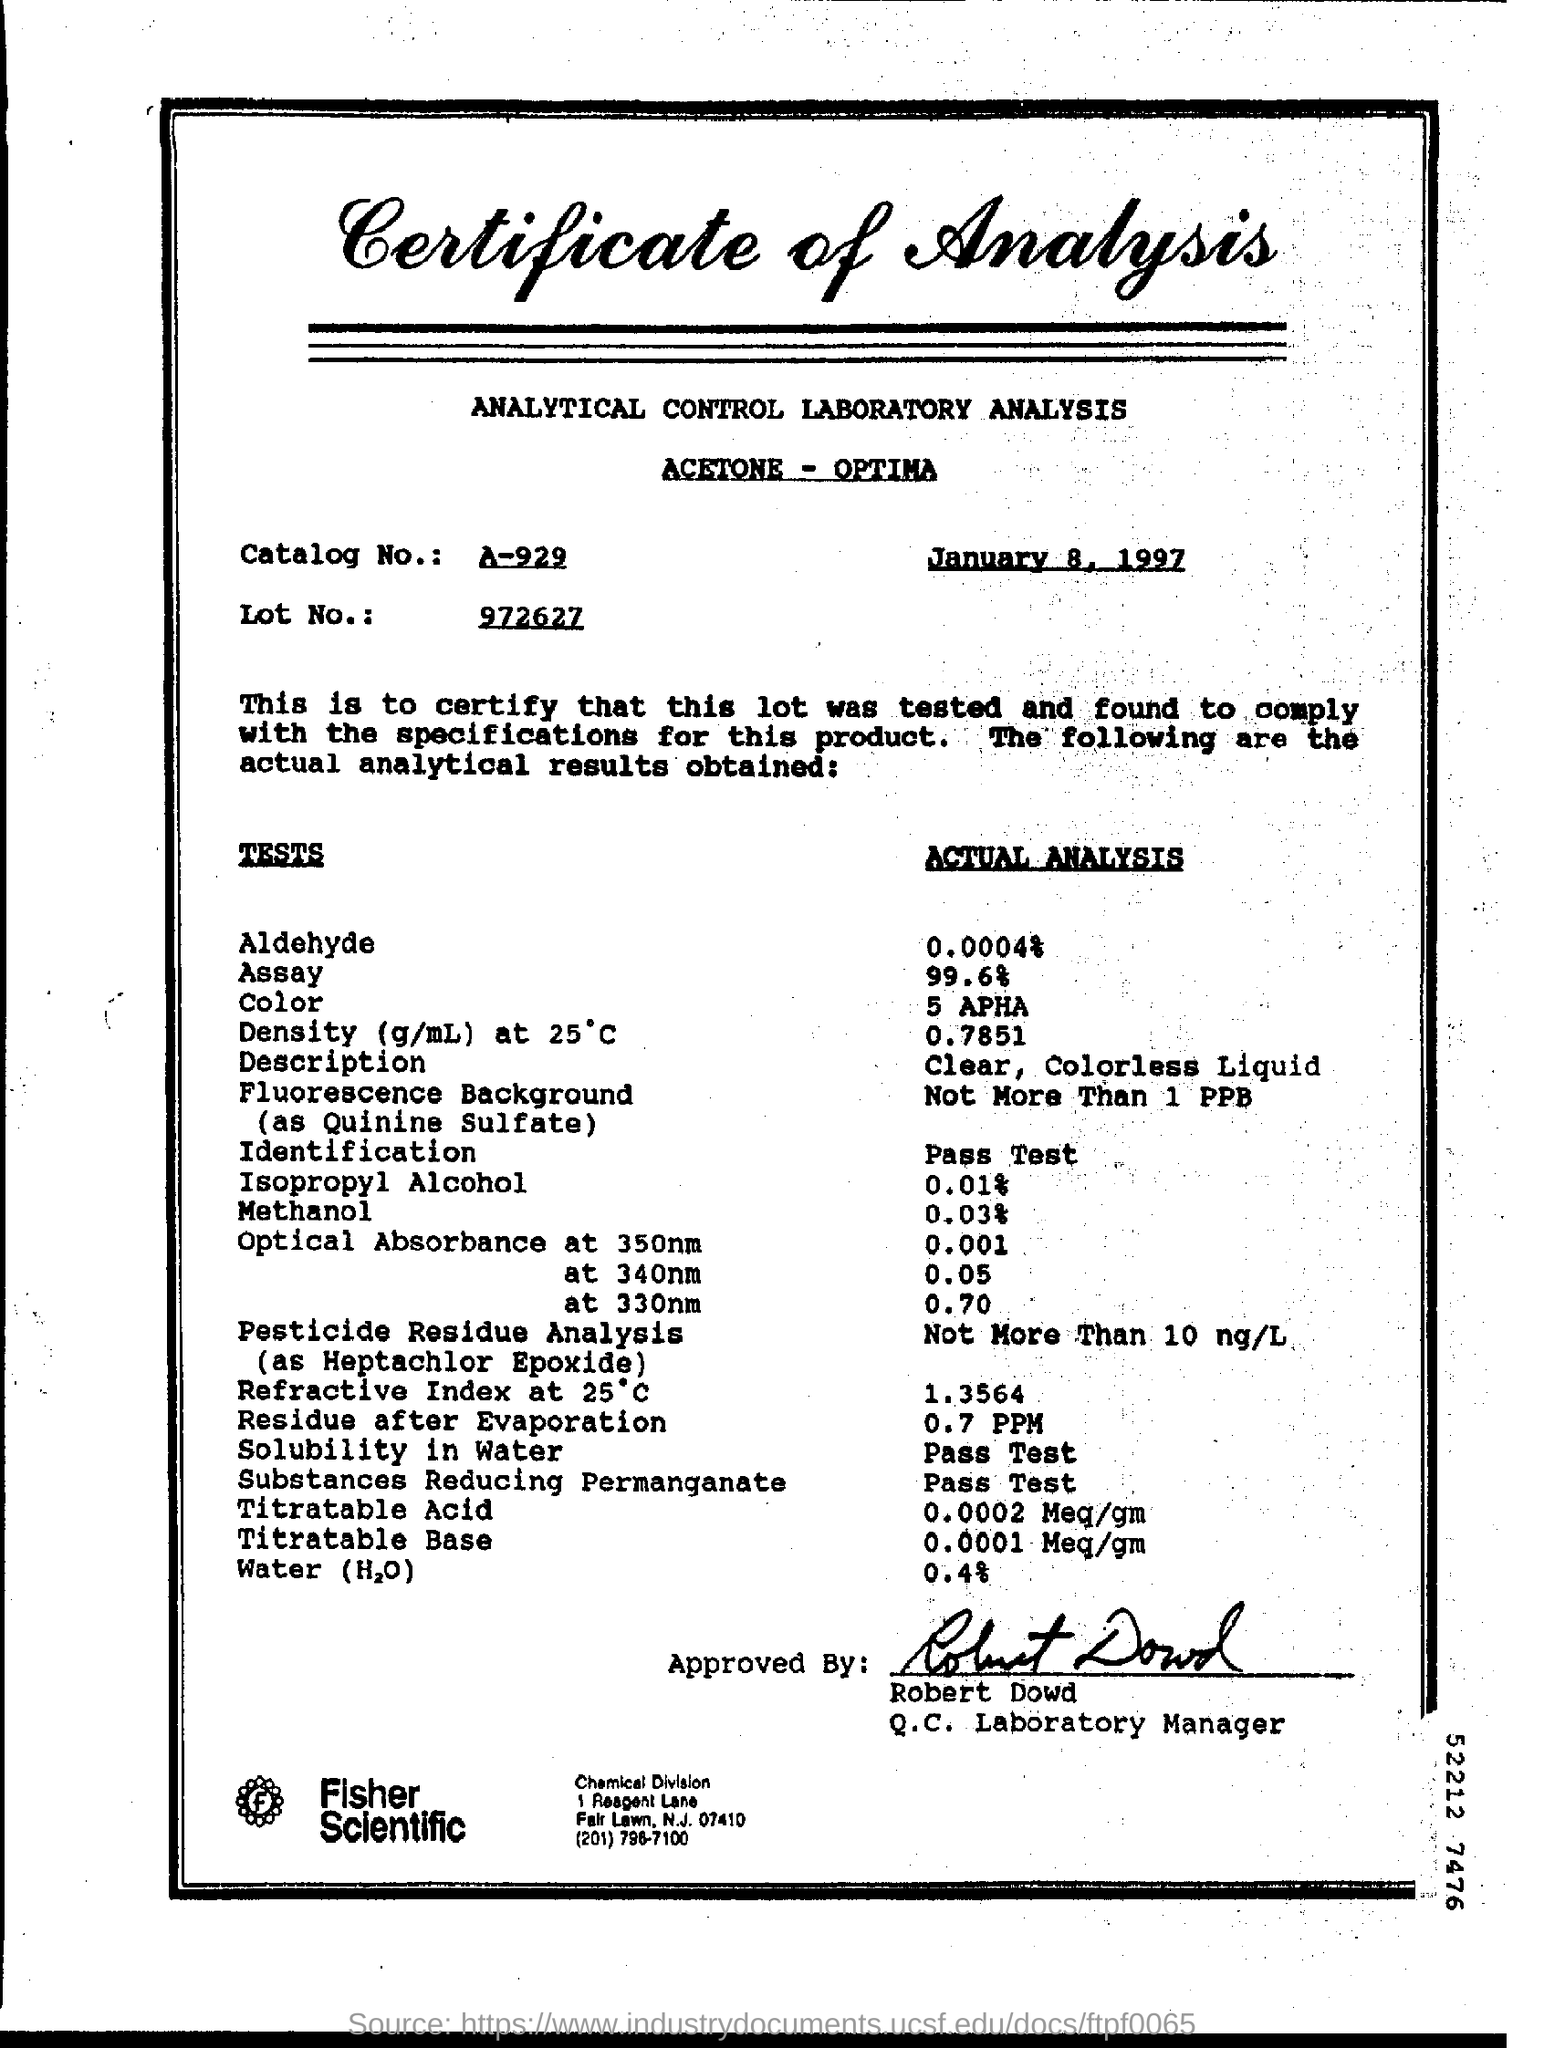What is the Title of the document ?
Give a very brief answer. Certificate of Analysis. What is the Catalog Number ?
Your answer should be very brief. A-929. What is the date mentioned in the top of the document ?
Ensure brevity in your answer.  January 8, 1997. What is the Lot Number ?
Offer a terse response. 972627. Who is the Q.C. Laboratory Manager ?
Keep it short and to the point. Robert Dowd. What is the Actual Analysis for Solubility in Water ?
Ensure brevity in your answer.  Pass test. What is the Actual Analysis for Methanol ?
Offer a very short reply. 0.03%. 